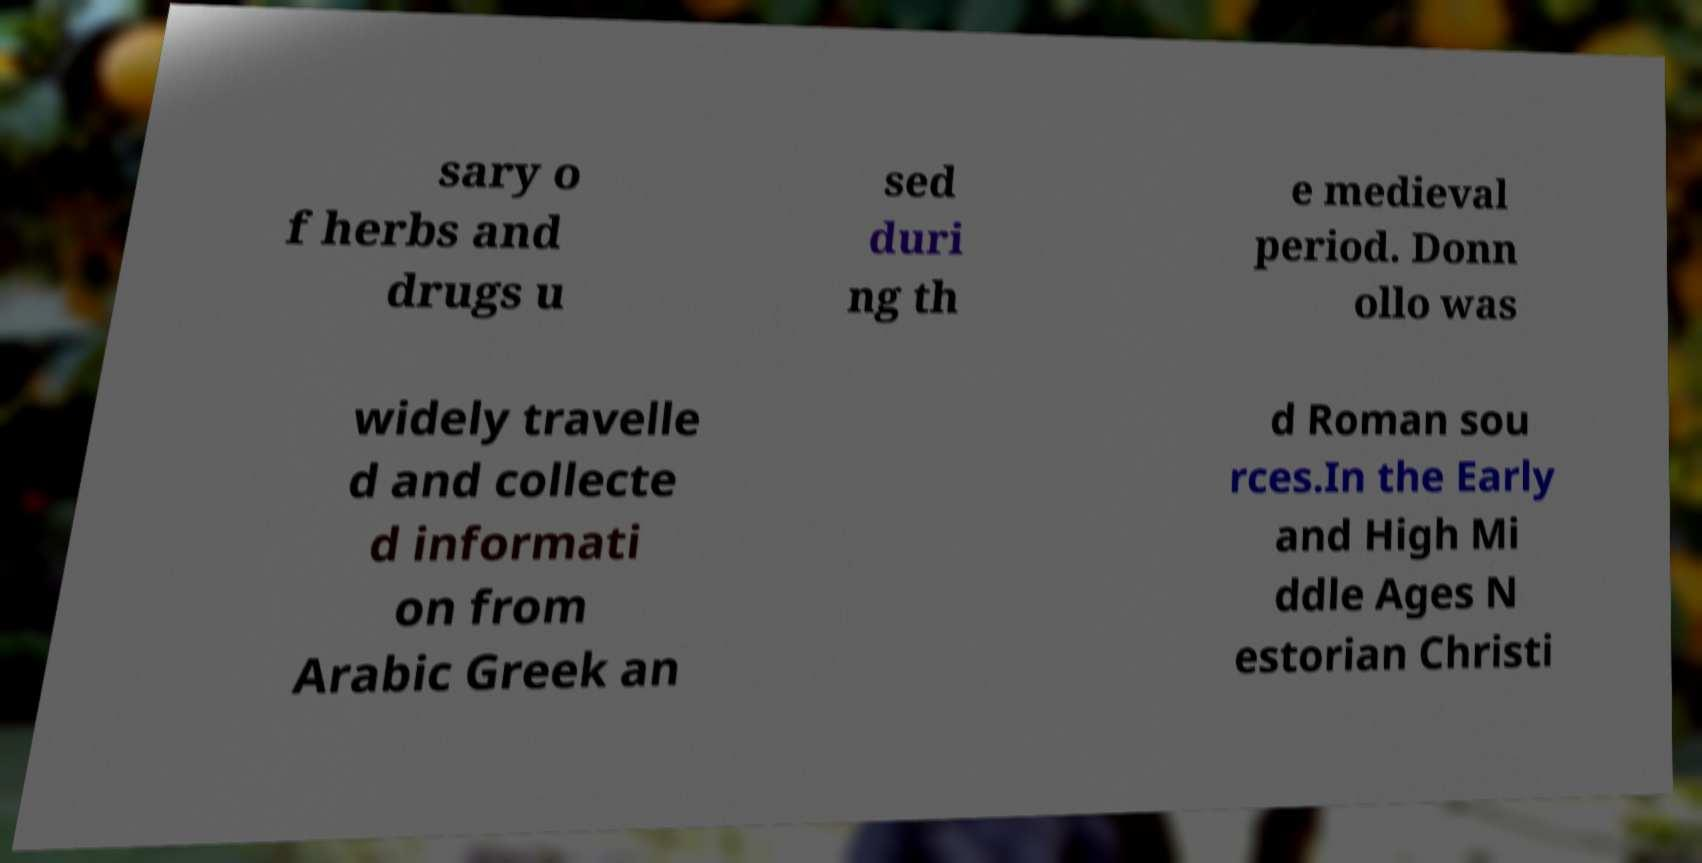There's text embedded in this image that I need extracted. Can you transcribe it verbatim? sary o f herbs and drugs u sed duri ng th e medieval period. Donn ollo was widely travelle d and collecte d informati on from Arabic Greek an d Roman sou rces.In the Early and High Mi ddle Ages N estorian Christi 